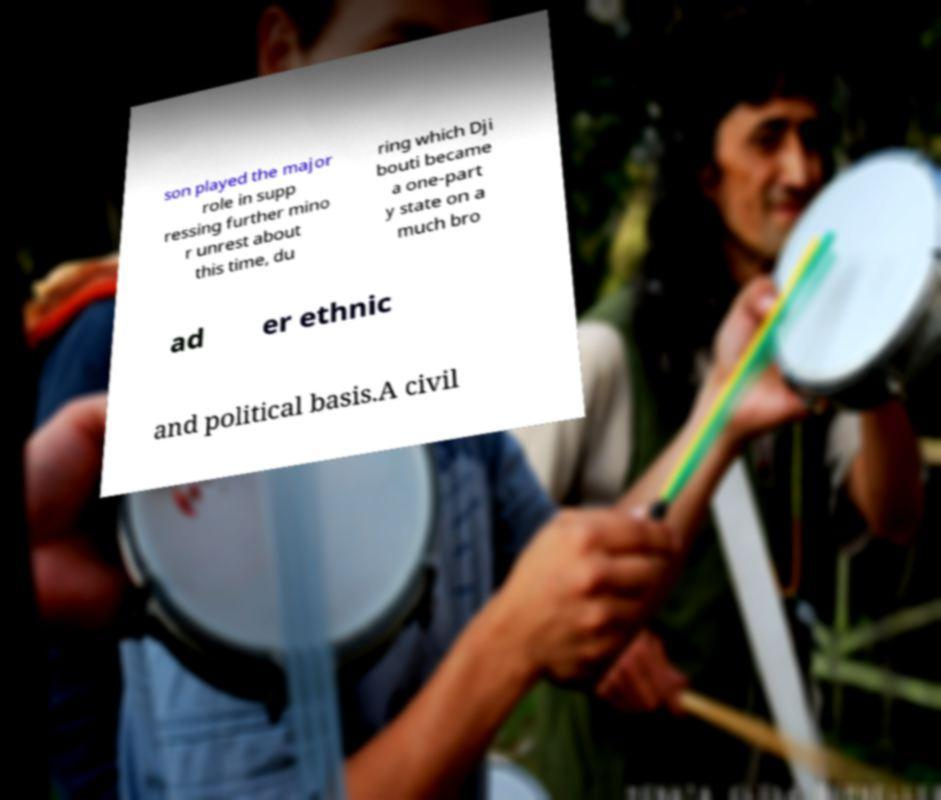Please read and relay the text visible in this image. What does it say? son played the major role in supp ressing further mino r unrest about this time, du ring which Dji bouti became a one-part y state on a much bro ad er ethnic and political basis.A civil 